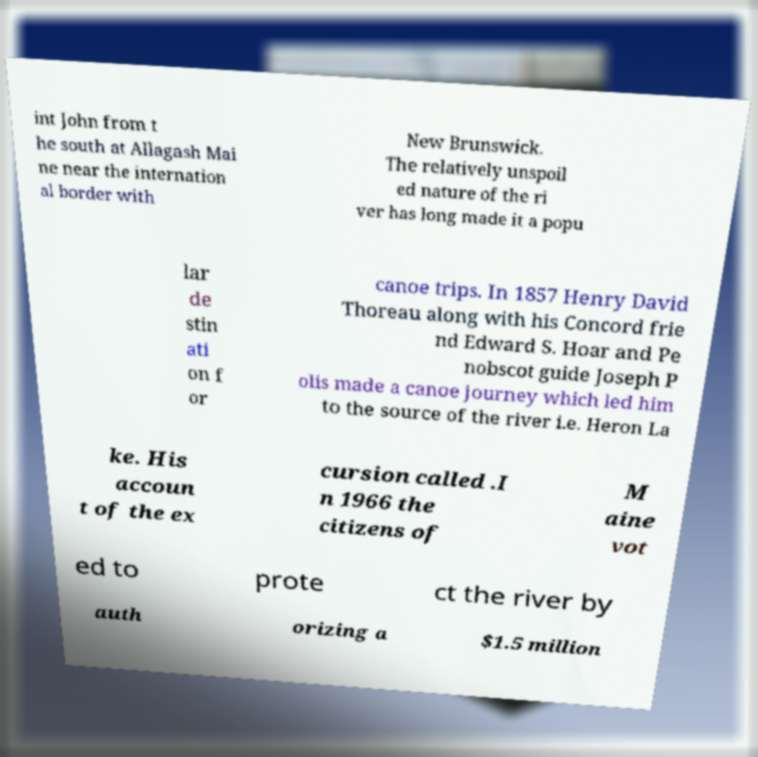Can you accurately transcribe the text from the provided image for me? int John from t he south at Allagash Mai ne near the internation al border with New Brunswick. The relatively unspoil ed nature of the ri ver has long made it a popu lar de stin ati on f or canoe trips. In 1857 Henry David Thoreau along with his Concord frie nd Edward S. Hoar and Pe nobscot guide Joseph P olis made a canoe journey which led him to the source of the river i.e. Heron La ke. His accoun t of the ex cursion called .I n 1966 the citizens of M aine vot ed to prote ct the river by auth orizing a $1.5 million 